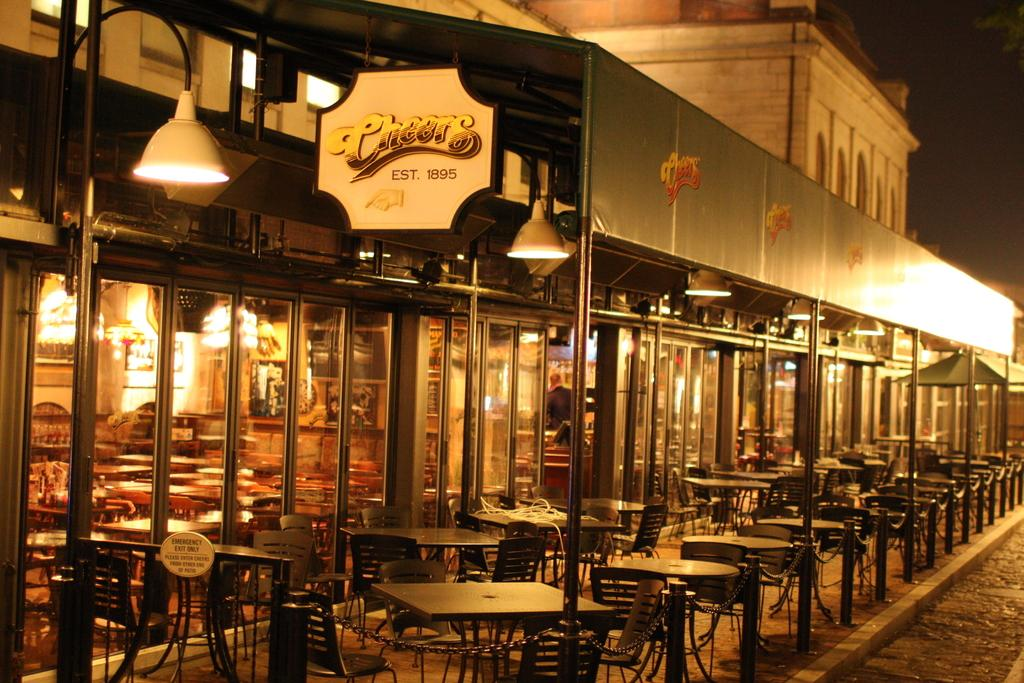What type of structure is in the image? There is a building in the image. What is located in front of the building? Tables and chairs are present in front of the building. Can you describe the seating arrangement in the image? There are chairs visible in the image. What type of lighting is attached to the building? There is a lamp attached to the wall of the building. What time of day is it in the image, considering the presence of the kitten? There is no kitten present in the image, so we cannot determine the time of day based on that information. 